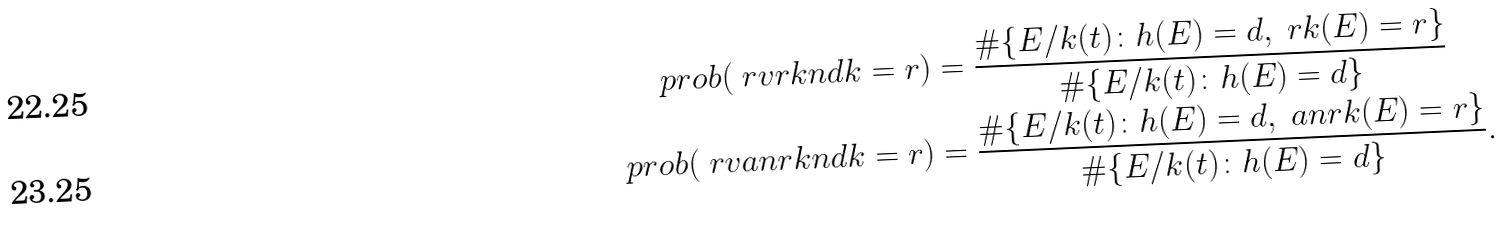Convert formula to latex. <formula><loc_0><loc_0><loc_500><loc_500>\ p r o b ( \ r v r k n d k = r ) & = \frac { \# \{ E / k ( t ) \colon h ( E ) = d , \ r k ( E ) = r \} } { \# \{ E / k ( t ) \colon h ( E ) = d \} } \\ \ p r o b ( \ r v a n r k n d k = r ) & = \frac { \# \{ E / k ( t ) \colon h ( E ) = d , \ a n r k ( E ) = r \} } { \# \{ E / k ( t ) \colon h ( E ) = d \} } .</formula> 